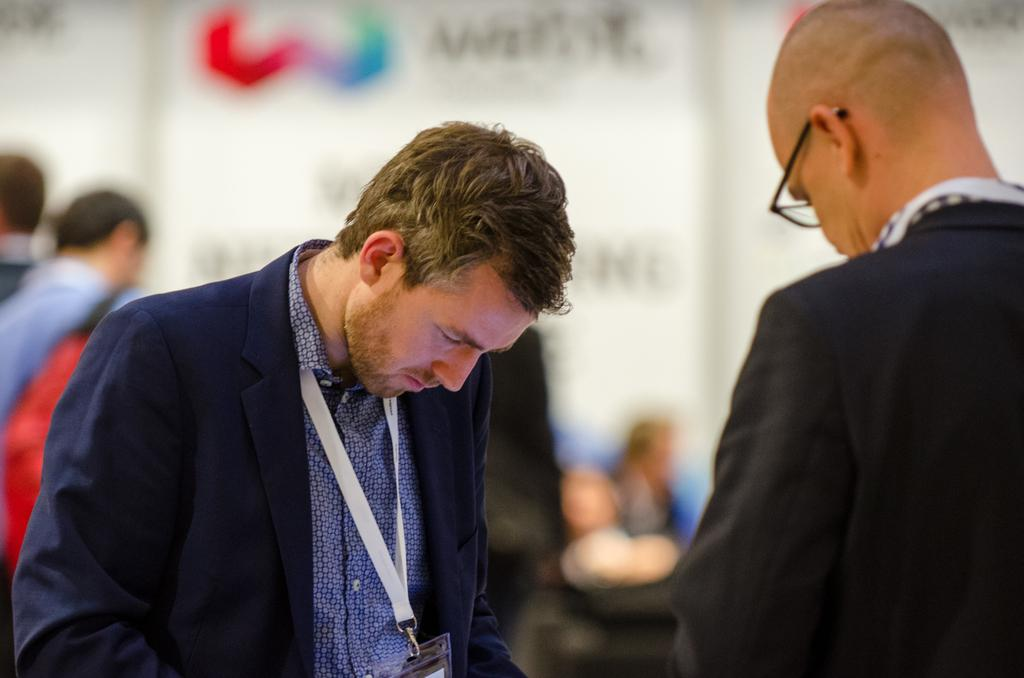Who are the main subjects in the foreground of the picture? There are two men wearing suits in the foreground of the picture. What can be seen in the background of the picture? There are people and banners in the background of the picture. How is the background of the image depicted? The background of the image is blurred. What type of grass can be seen growing near the light in the image? There is no grass or light present in the image. 